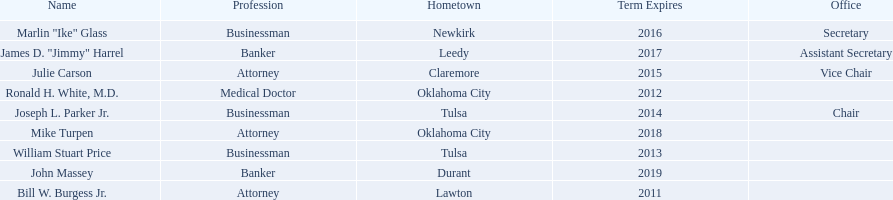What are all the names of oklahoma state regents for higher educations? Bill W. Burgess Jr., Ronald H. White, M.D., William Stuart Price, Joseph L. Parker Jr., Julie Carson, Marlin "Ike" Glass, James D. "Jimmy" Harrel, Mike Turpen, John Massey. Which ones are businessmen? William Stuart Price, Joseph L. Parker Jr., Marlin "Ike" Glass. Of those, who is from tulsa? William Stuart Price, Joseph L. Parker Jr. Whose term expires in 2014? Joseph L. Parker Jr. 